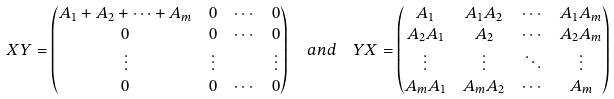<formula> <loc_0><loc_0><loc_500><loc_500>X Y & = \begin{pmatrix} A _ { 1 } + A _ { 2 } + \dots + A _ { m } & 0 & \cdots & 0 \\ 0 & 0 & \cdots & 0 \\ \vdots & \vdots & & \vdots \\ 0 & 0 & \cdots & 0 \end{pmatrix} \quad a n d \quad Y X = \begin{pmatrix} A _ { 1 } & A _ { 1 } A _ { 2 } & \cdots & A _ { 1 } A _ { m } \\ A _ { 2 } A _ { 1 } & A _ { 2 } & \cdots & A _ { 2 } A _ { m } \\ \vdots & \vdots & \ddots & \vdots \\ A _ { m } A _ { 1 } & A _ { m } A _ { 2 } & \cdots & A _ { m } \end{pmatrix}</formula> 